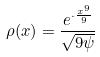<formula> <loc_0><loc_0><loc_500><loc_500>\rho ( x ) = \frac { e ^ { \cdot \frac { x ^ { 9 } } { 9 } } } { \sqrt { 9 \psi } }</formula> 